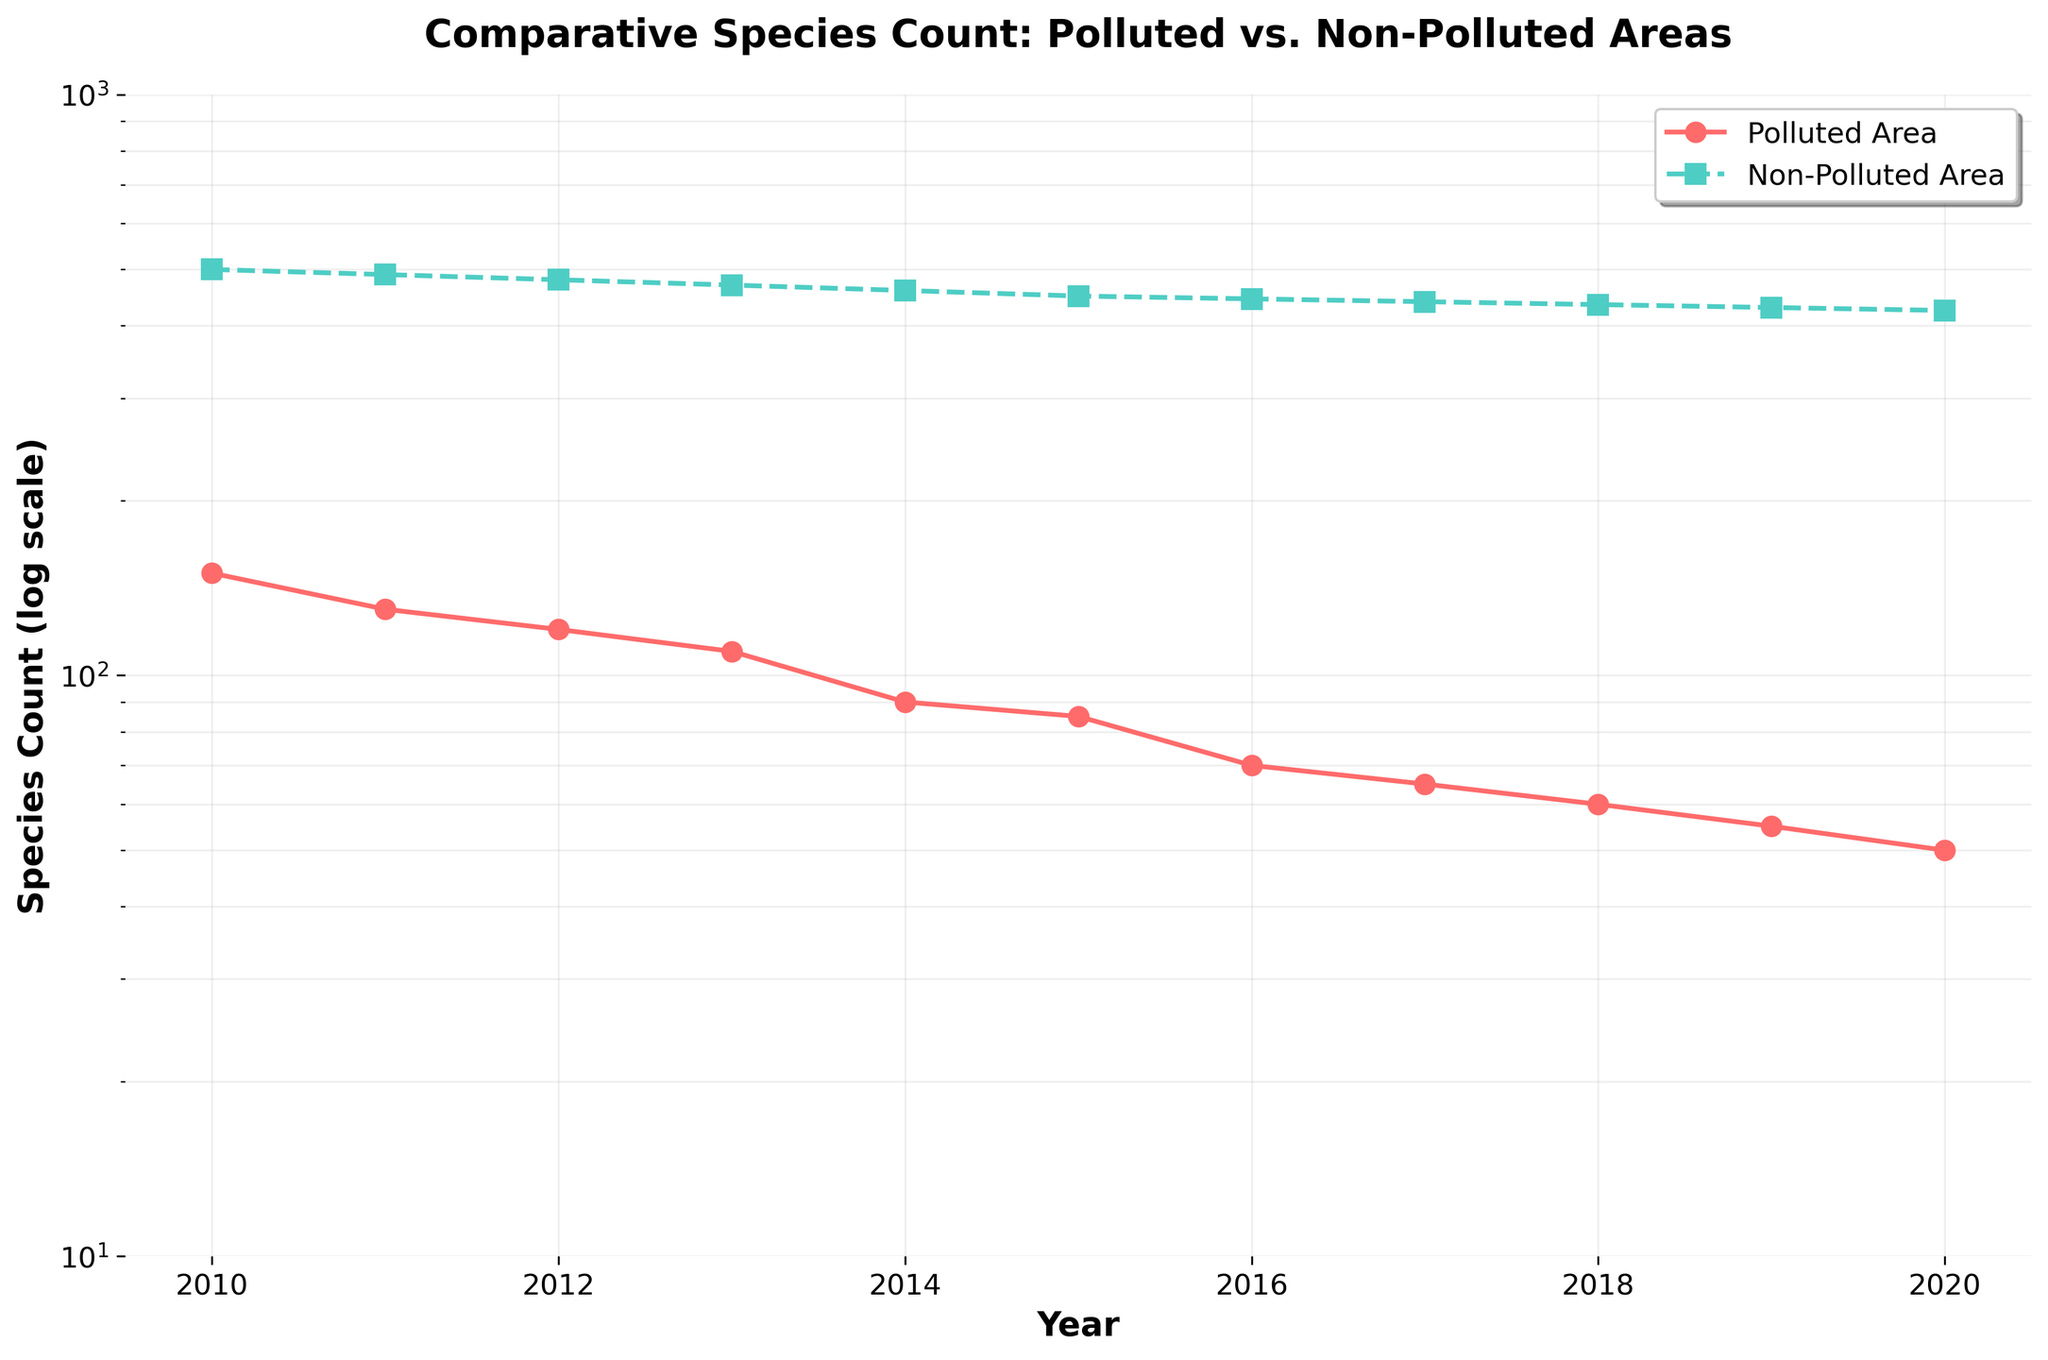When does the species count in polluted areas drop below 100? Observing the trend for the polluted area, the species count falls below 100 after 2014.
Answer: 2015 What is the title of the figure? The title is written at the top of the figure. It reads, "Comparative Species Count: Polluted vs. Non-Polluted Areas".
Answer: Comparative Species Count: Polluted vs. Non-Polluted Areas What are the y-axis limits of the figure? The y-axis limits can be seen on the vertical axis on the left side of the figure. The limits range from 10 to 1000.
Answer: 10 to 1000 Which area shows a more significant decline in species count over the decade? Comparing the steepness of the lines for both areas, the polluted area shows a more significant decline from 150 to 50 while the non-polluted area decreases more gradually from 500 to 425.
Answer: Polluted Area What is the slope of the trend in the non-polluted area from 2010 to 2020? The trend for the non-polluted area shows a consistent decline every year. A slope can be calculated as (425-500)/(2020-2010) which equals -7.5 species per year.
Answer: -7.5 species per year In which year did the species count in the polluted area hit 70? Checking the data points plotted, the polluted area's species count reached 70 in the year 2016.
Answer: 2016 How does the species count in the non-polluted area in 2020 compare to that in 2015? The species count for non-polluted areas in 2015 is approximately 450 and in 2020 it is 425. The comparison shows a reduction of 25 species.
Answer: 25 species reduction Which year's data shows the maximum difference in species count between polluted and non-polluted areas? By examining the gap between data points for each year, the maximum difference is in 2010, where the difference is 500 - 150 = 350 species.
Answer: 2010 What kind of plot is used to visualize the data? The visualization uses a line plot to show the trend over time with both solid and dashed lines for different categories (polluted vs. non-polluted areas).
Answer: Line plot How many data points are plotted for each area? Counting the markers present on each line, there are 11 data points for both the polluted and non-polluted areas, corresponding to the years 2010 to 2020.
Answer: 11 